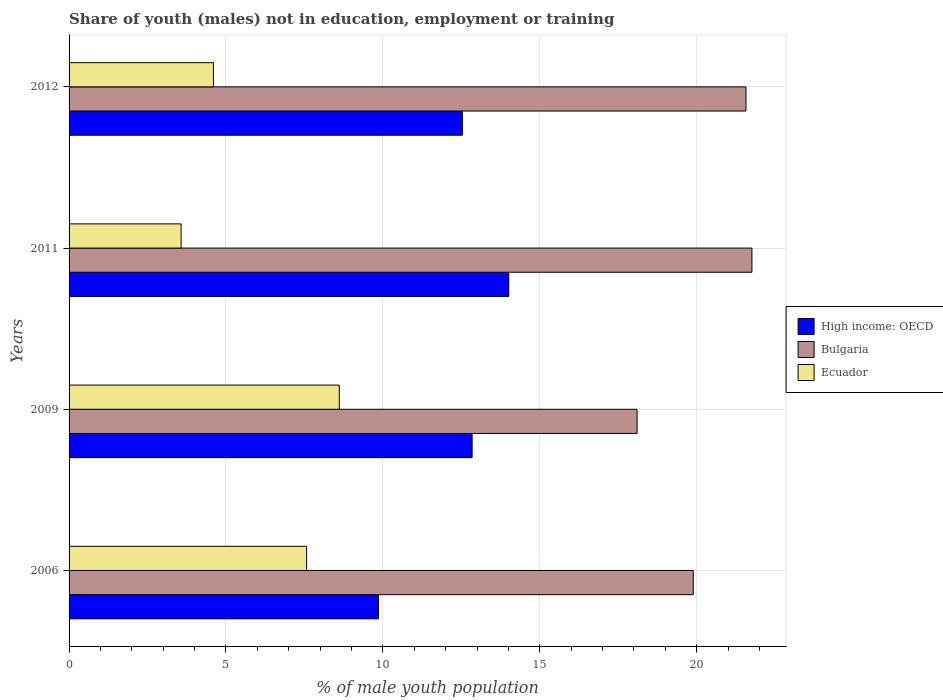How many groups of bars are there?
Provide a short and direct response. 4. Are the number of bars on each tick of the Y-axis equal?
Make the answer very short. Yes. How many bars are there on the 1st tick from the top?
Offer a very short reply. 3. How many bars are there on the 2nd tick from the bottom?
Your response must be concise. 3. What is the label of the 1st group of bars from the top?
Ensure brevity in your answer.  2012. In how many cases, is the number of bars for a given year not equal to the number of legend labels?
Offer a very short reply. 0. What is the percentage of unemployed males population in in High income: OECD in 2009?
Offer a terse response. 12.84. Across all years, what is the maximum percentage of unemployed males population in in Bulgaria?
Your answer should be very brief. 21.76. Across all years, what is the minimum percentage of unemployed males population in in Bulgaria?
Your answer should be very brief. 18.1. What is the total percentage of unemployed males population in in Bulgaria in the graph?
Provide a succinct answer. 81.32. What is the difference between the percentage of unemployed males population in in High income: OECD in 2009 and that in 2012?
Your answer should be very brief. 0.31. What is the difference between the percentage of unemployed males population in in Ecuador in 2006 and the percentage of unemployed males population in in High income: OECD in 2009?
Keep it short and to the point. -5.27. What is the average percentage of unemployed males population in in Bulgaria per year?
Ensure brevity in your answer.  20.33. In the year 2009, what is the difference between the percentage of unemployed males population in in Bulgaria and percentage of unemployed males population in in Ecuador?
Your response must be concise. 9.49. What is the ratio of the percentage of unemployed males population in in Bulgaria in 2006 to that in 2011?
Make the answer very short. 0.91. Is the percentage of unemployed males population in in High income: OECD in 2009 less than that in 2011?
Provide a short and direct response. Yes. What is the difference between the highest and the second highest percentage of unemployed males population in in Bulgaria?
Provide a short and direct response. 0.19. What is the difference between the highest and the lowest percentage of unemployed males population in in High income: OECD?
Your answer should be very brief. 4.15. Is the sum of the percentage of unemployed males population in in Bulgaria in 2006 and 2009 greater than the maximum percentage of unemployed males population in in High income: OECD across all years?
Your answer should be very brief. Yes. What does the 1st bar from the top in 2009 represents?
Offer a very short reply. Ecuador. What does the 3rd bar from the bottom in 2011 represents?
Keep it short and to the point. Ecuador. Are all the bars in the graph horizontal?
Your answer should be compact. Yes. How many years are there in the graph?
Your answer should be very brief. 4. What is the difference between two consecutive major ticks on the X-axis?
Provide a short and direct response. 5. Are the values on the major ticks of X-axis written in scientific E-notation?
Your answer should be compact. No. Where does the legend appear in the graph?
Your answer should be compact. Center right. What is the title of the graph?
Your response must be concise. Share of youth (males) not in education, employment or training. What is the label or title of the X-axis?
Ensure brevity in your answer.  % of male youth population. What is the % of male youth population in High income: OECD in 2006?
Provide a succinct answer. 9.86. What is the % of male youth population in Bulgaria in 2006?
Provide a short and direct response. 19.89. What is the % of male youth population in Ecuador in 2006?
Provide a short and direct response. 7.57. What is the % of male youth population of High income: OECD in 2009?
Provide a succinct answer. 12.84. What is the % of male youth population of Bulgaria in 2009?
Provide a short and direct response. 18.1. What is the % of male youth population of Ecuador in 2009?
Make the answer very short. 8.61. What is the % of male youth population in High income: OECD in 2011?
Make the answer very short. 14.01. What is the % of male youth population of Bulgaria in 2011?
Provide a succinct answer. 21.76. What is the % of male youth population of Ecuador in 2011?
Make the answer very short. 3.57. What is the % of male youth population in High income: OECD in 2012?
Your answer should be very brief. 12.53. What is the % of male youth population of Bulgaria in 2012?
Provide a succinct answer. 21.57. What is the % of male youth population in Ecuador in 2012?
Keep it short and to the point. 4.6. Across all years, what is the maximum % of male youth population of High income: OECD?
Offer a very short reply. 14.01. Across all years, what is the maximum % of male youth population in Bulgaria?
Provide a short and direct response. 21.76. Across all years, what is the maximum % of male youth population in Ecuador?
Give a very brief answer. 8.61. Across all years, what is the minimum % of male youth population in High income: OECD?
Provide a short and direct response. 9.86. Across all years, what is the minimum % of male youth population of Bulgaria?
Your answer should be compact. 18.1. Across all years, what is the minimum % of male youth population in Ecuador?
Your answer should be compact. 3.57. What is the total % of male youth population of High income: OECD in the graph?
Offer a terse response. 49.25. What is the total % of male youth population of Bulgaria in the graph?
Your response must be concise. 81.32. What is the total % of male youth population of Ecuador in the graph?
Your response must be concise. 24.35. What is the difference between the % of male youth population in High income: OECD in 2006 and that in 2009?
Offer a terse response. -2.98. What is the difference between the % of male youth population of Bulgaria in 2006 and that in 2009?
Make the answer very short. 1.79. What is the difference between the % of male youth population of Ecuador in 2006 and that in 2009?
Your answer should be compact. -1.04. What is the difference between the % of male youth population in High income: OECD in 2006 and that in 2011?
Make the answer very short. -4.15. What is the difference between the % of male youth population in Bulgaria in 2006 and that in 2011?
Give a very brief answer. -1.87. What is the difference between the % of male youth population of High income: OECD in 2006 and that in 2012?
Keep it short and to the point. -2.67. What is the difference between the % of male youth population of Bulgaria in 2006 and that in 2012?
Provide a short and direct response. -1.68. What is the difference between the % of male youth population in Ecuador in 2006 and that in 2012?
Make the answer very short. 2.97. What is the difference between the % of male youth population of High income: OECD in 2009 and that in 2011?
Provide a succinct answer. -1.17. What is the difference between the % of male youth population in Bulgaria in 2009 and that in 2011?
Provide a succinct answer. -3.66. What is the difference between the % of male youth population in Ecuador in 2009 and that in 2011?
Make the answer very short. 5.04. What is the difference between the % of male youth population in High income: OECD in 2009 and that in 2012?
Offer a terse response. 0.31. What is the difference between the % of male youth population of Bulgaria in 2009 and that in 2012?
Give a very brief answer. -3.47. What is the difference between the % of male youth population of Ecuador in 2009 and that in 2012?
Make the answer very short. 4.01. What is the difference between the % of male youth population of High income: OECD in 2011 and that in 2012?
Provide a short and direct response. 1.48. What is the difference between the % of male youth population in Bulgaria in 2011 and that in 2012?
Give a very brief answer. 0.19. What is the difference between the % of male youth population of Ecuador in 2011 and that in 2012?
Provide a short and direct response. -1.03. What is the difference between the % of male youth population in High income: OECD in 2006 and the % of male youth population in Bulgaria in 2009?
Give a very brief answer. -8.24. What is the difference between the % of male youth population of High income: OECD in 2006 and the % of male youth population of Ecuador in 2009?
Offer a terse response. 1.25. What is the difference between the % of male youth population in Bulgaria in 2006 and the % of male youth population in Ecuador in 2009?
Give a very brief answer. 11.28. What is the difference between the % of male youth population in High income: OECD in 2006 and the % of male youth population in Bulgaria in 2011?
Make the answer very short. -11.9. What is the difference between the % of male youth population of High income: OECD in 2006 and the % of male youth population of Ecuador in 2011?
Provide a succinct answer. 6.29. What is the difference between the % of male youth population in Bulgaria in 2006 and the % of male youth population in Ecuador in 2011?
Make the answer very short. 16.32. What is the difference between the % of male youth population of High income: OECD in 2006 and the % of male youth population of Bulgaria in 2012?
Offer a terse response. -11.71. What is the difference between the % of male youth population of High income: OECD in 2006 and the % of male youth population of Ecuador in 2012?
Your answer should be very brief. 5.26. What is the difference between the % of male youth population in Bulgaria in 2006 and the % of male youth population in Ecuador in 2012?
Your answer should be compact. 15.29. What is the difference between the % of male youth population of High income: OECD in 2009 and the % of male youth population of Bulgaria in 2011?
Provide a short and direct response. -8.92. What is the difference between the % of male youth population of High income: OECD in 2009 and the % of male youth population of Ecuador in 2011?
Give a very brief answer. 9.27. What is the difference between the % of male youth population in Bulgaria in 2009 and the % of male youth population in Ecuador in 2011?
Offer a very short reply. 14.53. What is the difference between the % of male youth population in High income: OECD in 2009 and the % of male youth population in Bulgaria in 2012?
Provide a succinct answer. -8.73. What is the difference between the % of male youth population in High income: OECD in 2009 and the % of male youth population in Ecuador in 2012?
Provide a short and direct response. 8.24. What is the difference between the % of male youth population in High income: OECD in 2011 and the % of male youth population in Bulgaria in 2012?
Provide a short and direct response. -7.56. What is the difference between the % of male youth population of High income: OECD in 2011 and the % of male youth population of Ecuador in 2012?
Your answer should be very brief. 9.41. What is the difference between the % of male youth population in Bulgaria in 2011 and the % of male youth population in Ecuador in 2012?
Provide a short and direct response. 17.16. What is the average % of male youth population of High income: OECD per year?
Your answer should be very brief. 12.31. What is the average % of male youth population of Bulgaria per year?
Provide a succinct answer. 20.33. What is the average % of male youth population in Ecuador per year?
Your answer should be very brief. 6.09. In the year 2006, what is the difference between the % of male youth population of High income: OECD and % of male youth population of Bulgaria?
Keep it short and to the point. -10.03. In the year 2006, what is the difference between the % of male youth population of High income: OECD and % of male youth population of Ecuador?
Keep it short and to the point. 2.29. In the year 2006, what is the difference between the % of male youth population in Bulgaria and % of male youth population in Ecuador?
Offer a very short reply. 12.32. In the year 2009, what is the difference between the % of male youth population in High income: OECD and % of male youth population in Bulgaria?
Keep it short and to the point. -5.26. In the year 2009, what is the difference between the % of male youth population in High income: OECD and % of male youth population in Ecuador?
Your answer should be compact. 4.23. In the year 2009, what is the difference between the % of male youth population of Bulgaria and % of male youth population of Ecuador?
Your response must be concise. 9.49. In the year 2011, what is the difference between the % of male youth population in High income: OECD and % of male youth population in Bulgaria?
Your answer should be very brief. -7.75. In the year 2011, what is the difference between the % of male youth population of High income: OECD and % of male youth population of Ecuador?
Make the answer very short. 10.44. In the year 2011, what is the difference between the % of male youth population in Bulgaria and % of male youth population in Ecuador?
Your answer should be compact. 18.19. In the year 2012, what is the difference between the % of male youth population of High income: OECD and % of male youth population of Bulgaria?
Provide a succinct answer. -9.04. In the year 2012, what is the difference between the % of male youth population in High income: OECD and % of male youth population in Ecuador?
Provide a short and direct response. 7.93. In the year 2012, what is the difference between the % of male youth population in Bulgaria and % of male youth population in Ecuador?
Your response must be concise. 16.97. What is the ratio of the % of male youth population in High income: OECD in 2006 to that in 2009?
Offer a very short reply. 0.77. What is the ratio of the % of male youth population in Bulgaria in 2006 to that in 2009?
Give a very brief answer. 1.1. What is the ratio of the % of male youth population in Ecuador in 2006 to that in 2009?
Your response must be concise. 0.88. What is the ratio of the % of male youth population in High income: OECD in 2006 to that in 2011?
Offer a terse response. 0.7. What is the ratio of the % of male youth population in Bulgaria in 2006 to that in 2011?
Give a very brief answer. 0.91. What is the ratio of the % of male youth population of Ecuador in 2006 to that in 2011?
Ensure brevity in your answer.  2.12. What is the ratio of the % of male youth population of High income: OECD in 2006 to that in 2012?
Provide a short and direct response. 0.79. What is the ratio of the % of male youth population of Bulgaria in 2006 to that in 2012?
Ensure brevity in your answer.  0.92. What is the ratio of the % of male youth population in Ecuador in 2006 to that in 2012?
Offer a very short reply. 1.65. What is the ratio of the % of male youth population of High income: OECD in 2009 to that in 2011?
Keep it short and to the point. 0.92. What is the ratio of the % of male youth population in Bulgaria in 2009 to that in 2011?
Make the answer very short. 0.83. What is the ratio of the % of male youth population in Ecuador in 2009 to that in 2011?
Your answer should be compact. 2.41. What is the ratio of the % of male youth population in High income: OECD in 2009 to that in 2012?
Your response must be concise. 1.02. What is the ratio of the % of male youth population of Bulgaria in 2009 to that in 2012?
Your answer should be compact. 0.84. What is the ratio of the % of male youth population of Ecuador in 2009 to that in 2012?
Offer a terse response. 1.87. What is the ratio of the % of male youth population of High income: OECD in 2011 to that in 2012?
Your answer should be compact. 1.12. What is the ratio of the % of male youth population in Bulgaria in 2011 to that in 2012?
Your answer should be compact. 1.01. What is the ratio of the % of male youth population in Ecuador in 2011 to that in 2012?
Your answer should be very brief. 0.78. What is the difference between the highest and the second highest % of male youth population in High income: OECD?
Ensure brevity in your answer.  1.17. What is the difference between the highest and the second highest % of male youth population in Bulgaria?
Provide a succinct answer. 0.19. What is the difference between the highest and the second highest % of male youth population of Ecuador?
Give a very brief answer. 1.04. What is the difference between the highest and the lowest % of male youth population in High income: OECD?
Give a very brief answer. 4.15. What is the difference between the highest and the lowest % of male youth population in Bulgaria?
Your response must be concise. 3.66. What is the difference between the highest and the lowest % of male youth population in Ecuador?
Ensure brevity in your answer.  5.04. 